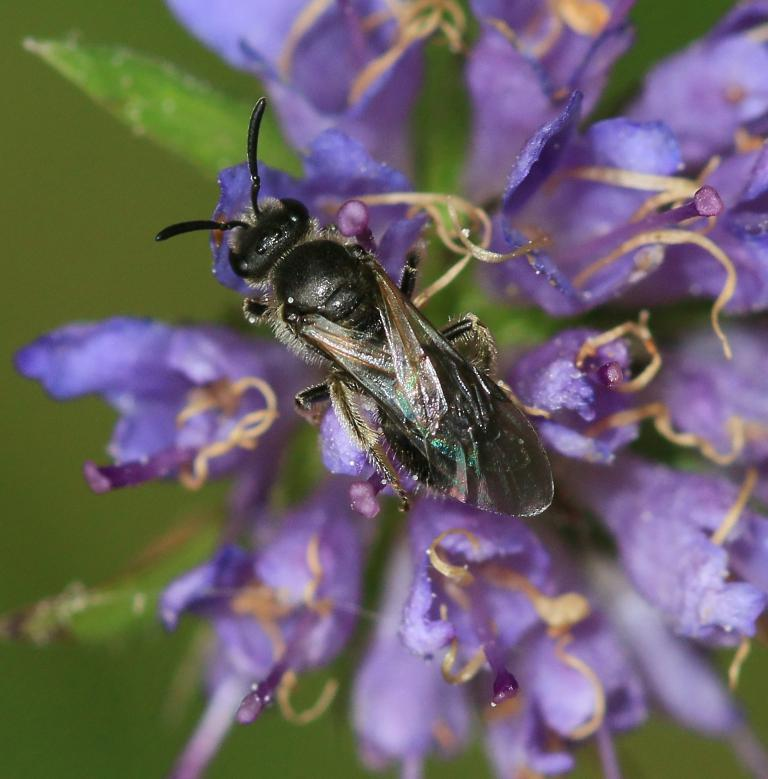What type of flower is present in the image? There is a violet color flower in the image. Is there anything else on the flower besides its petals? Yes, there is an insect on the flower. How would you describe the background of the image? The background of the image is green and blurred. How many quarters can be seen on the top of the flower in the image? There are no quarters present in the image; it features a flower with an insect on it. What type of cracker is visible on the flower in the image? There are no crackers present in the image; it features a flower with an insect on it. 